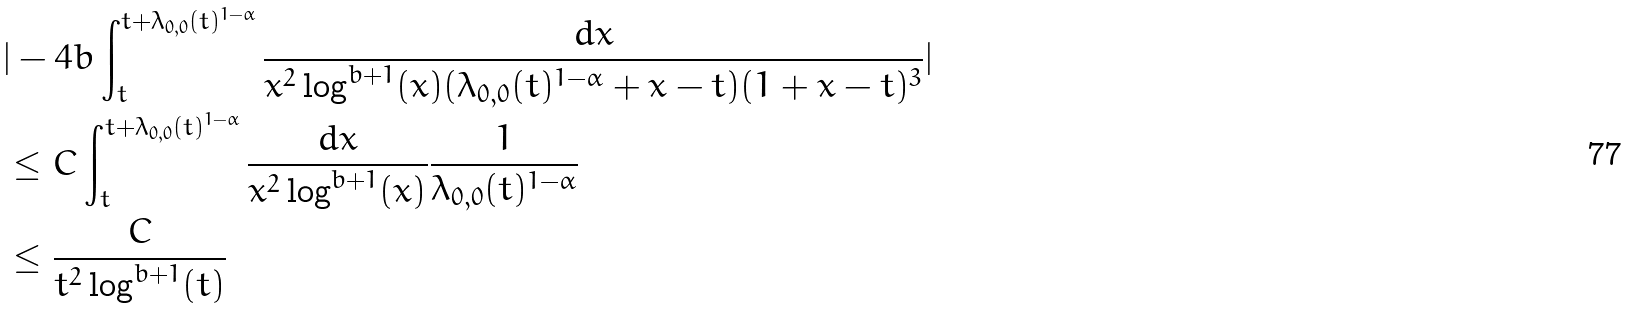<formula> <loc_0><loc_0><loc_500><loc_500>& | - 4 b \int _ { t } ^ { t + \lambda _ { 0 , 0 } ( t ) ^ { 1 - \alpha } } \frac { d x } { x ^ { 2 } \log ^ { b + 1 } ( x ) ( \lambda _ { 0 , 0 } ( t ) ^ { 1 - \alpha } + x - t ) ( 1 + x - t ) ^ { 3 } } | \\ & \leq C \int _ { t } ^ { t + \lambda _ { 0 , 0 } ( t ) ^ { 1 - \alpha } } \frac { d x } { x ^ { 2 } \log ^ { b + 1 } ( x ) } \frac { 1 } { \lambda _ { 0 , 0 } ( t ) ^ { 1 - \alpha } } \\ & \leq \frac { C } { t ^ { 2 } \log ^ { b + 1 } ( t ) }</formula> 